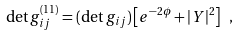Convert formula to latex. <formula><loc_0><loc_0><loc_500><loc_500>\det g _ { i j } ^ { ( 1 1 ) } = ( \det g _ { i j } ) \left [ e ^ { - 2 \phi } + | Y | ^ { 2 } \right ] \ ,</formula> 